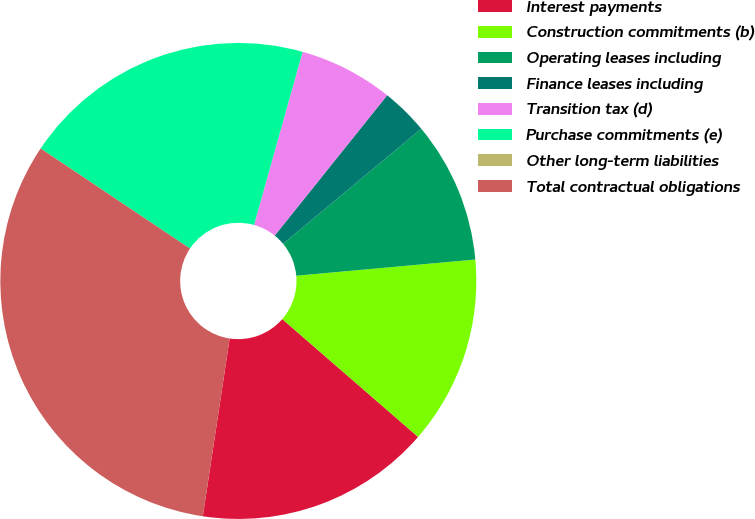<chart> <loc_0><loc_0><loc_500><loc_500><pie_chart><fcel>Interest payments<fcel>Construction commitments (b)<fcel>Operating leases including<fcel>Finance leases including<fcel>Transition tax (d)<fcel>Purchase commitments (e)<fcel>Other long-term liabilities<fcel>Total contractual obligations<nl><fcel>16.01%<fcel>12.81%<fcel>9.61%<fcel>3.2%<fcel>6.4%<fcel>19.96%<fcel>0.0%<fcel>32.01%<nl></chart> 